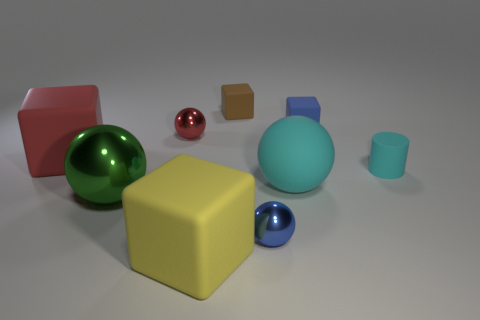Add 1 tiny red metal balls. How many objects exist? 10 Subtract all blocks. How many objects are left? 5 Add 4 large green metal things. How many large green metal things exist? 5 Subtract 0 purple cubes. How many objects are left? 9 Subtract all blue rubber cylinders. Subtract all blue matte blocks. How many objects are left? 8 Add 2 big cyan matte spheres. How many big cyan matte spheres are left? 3 